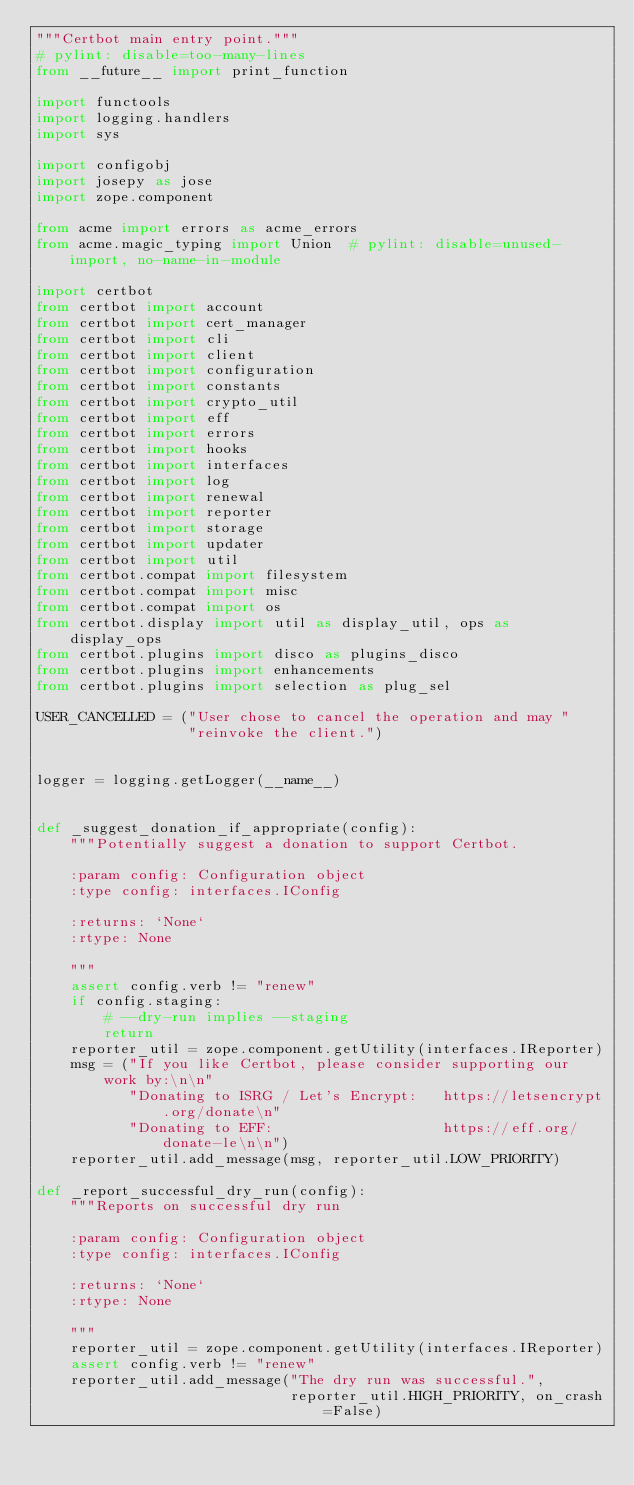Convert code to text. <code><loc_0><loc_0><loc_500><loc_500><_Python_>"""Certbot main entry point."""
# pylint: disable=too-many-lines
from __future__ import print_function

import functools
import logging.handlers
import sys

import configobj
import josepy as jose
import zope.component

from acme import errors as acme_errors
from acme.magic_typing import Union  # pylint: disable=unused-import, no-name-in-module

import certbot
from certbot import account
from certbot import cert_manager
from certbot import cli
from certbot import client
from certbot import configuration
from certbot import constants
from certbot import crypto_util
from certbot import eff
from certbot import errors
from certbot import hooks
from certbot import interfaces
from certbot import log
from certbot import renewal
from certbot import reporter
from certbot import storage
from certbot import updater
from certbot import util
from certbot.compat import filesystem
from certbot.compat import misc
from certbot.compat import os
from certbot.display import util as display_util, ops as display_ops
from certbot.plugins import disco as plugins_disco
from certbot.plugins import enhancements
from certbot.plugins import selection as plug_sel

USER_CANCELLED = ("User chose to cancel the operation and may "
                  "reinvoke the client.")


logger = logging.getLogger(__name__)


def _suggest_donation_if_appropriate(config):
    """Potentially suggest a donation to support Certbot.

    :param config: Configuration object
    :type config: interfaces.IConfig

    :returns: `None`
    :rtype: None

    """
    assert config.verb != "renew"
    if config.staging:
        # --dry-run implies --staging
        return
    reporter_util = zope.component.getUtility(interfaces.IReporter)
    msg = ("If you like Certbot, please consider supporting our work by:\n\n"
           "Donating to ISRG / Let's Encrypt:   https://letsencrypt.org/donate\n"
           "Donating to EFF:                    https://eff.org/donate-le\n\n")
    reporter_util.add_message(msg, reporter_util.LOW_PRIORITY)

def _report_successful_dry_run(config):
    """Reports on successful dry run

    :param config: Configuration object
    :type config: interfaces.IConfig

    :returns: `None`
    :rtype: None

    """
    reporter_util = zope.component.getUtility(interfaces.IReporter)
    assert config.verb != "renew"
    reporter_util.add_message("The dry run was successful.",
                              reporter_util.HIGH_PRIORITY, on_crash=False)

</code> 